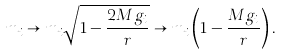<formula> <loc_0><loc_0><loc_500><loc_500>m _ { i } \to m _ { i } \sqrt { 1 - \frac { 2 M g _ { i } } { r } } \to m _ { i } \left ( 1 - \frac { M g _ { i } } { r } \right ) .</formula> 